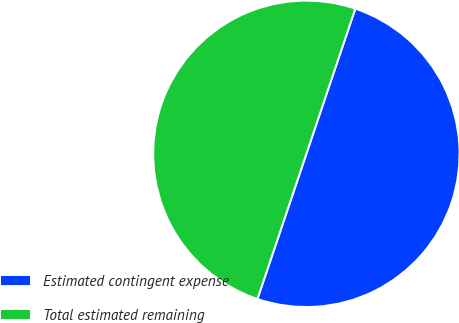Convert chart. <chart><loc_0><loc_0><loc_500><loc_500><pie_chart><fcel>Estimated contingent expense<fcel>Total estimated remaining<nl><fcel>50.0%<fcel>50.0%<nl></chart> 